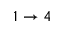Convert formula to latex. <formula><loc_0><loc_0><loc_500><loc_500>1 \to 4</formula> 